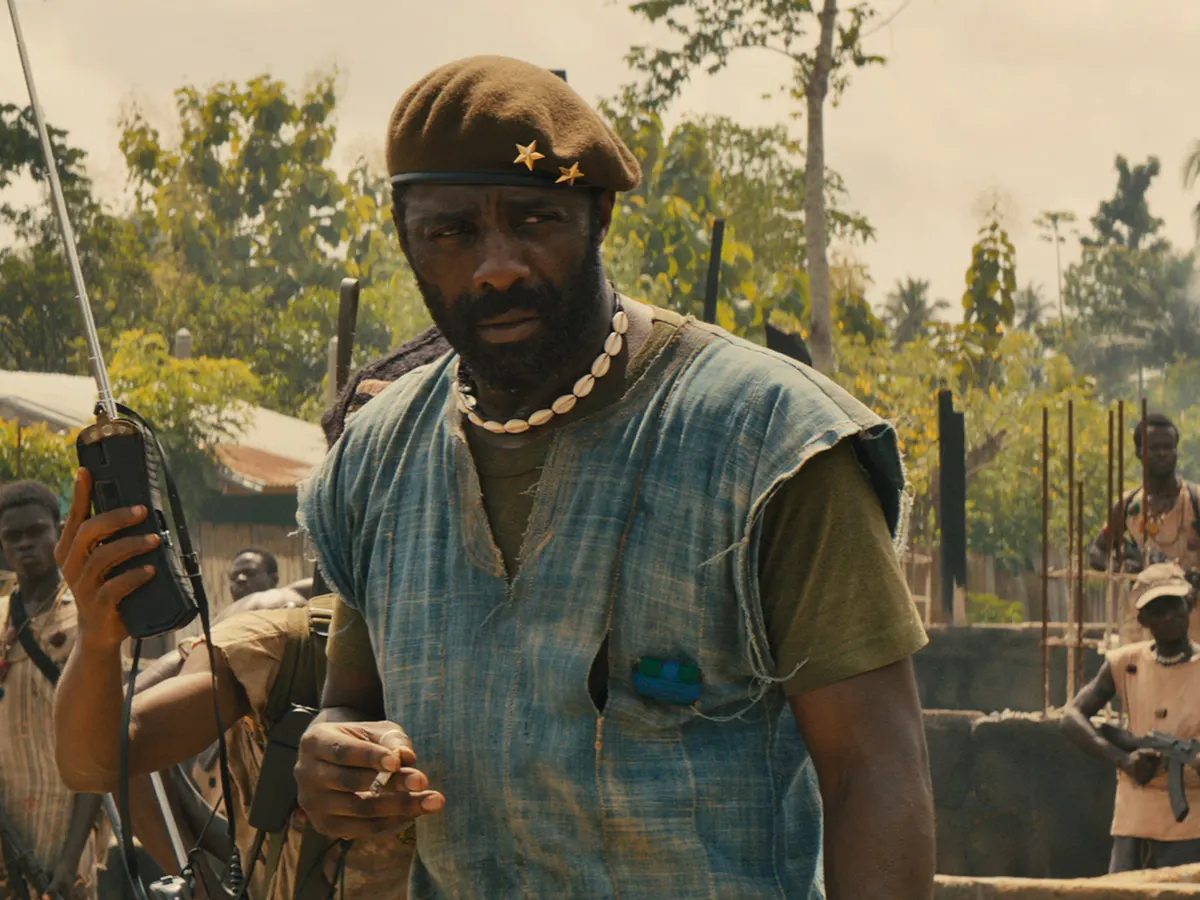What do you think the mood of the group behind the man is, and what might they be feeling? The mood of the group in the background appears tense and focused, indicative of a high-stress environment typical of conflict zones. The soldiers seem attentive and serious, suggesting they are acutely aware of the gravity of the situation and the importance of the commands being given. One could infer a mix of determination, apprehension, and readiness to act from their body language and expressions. 